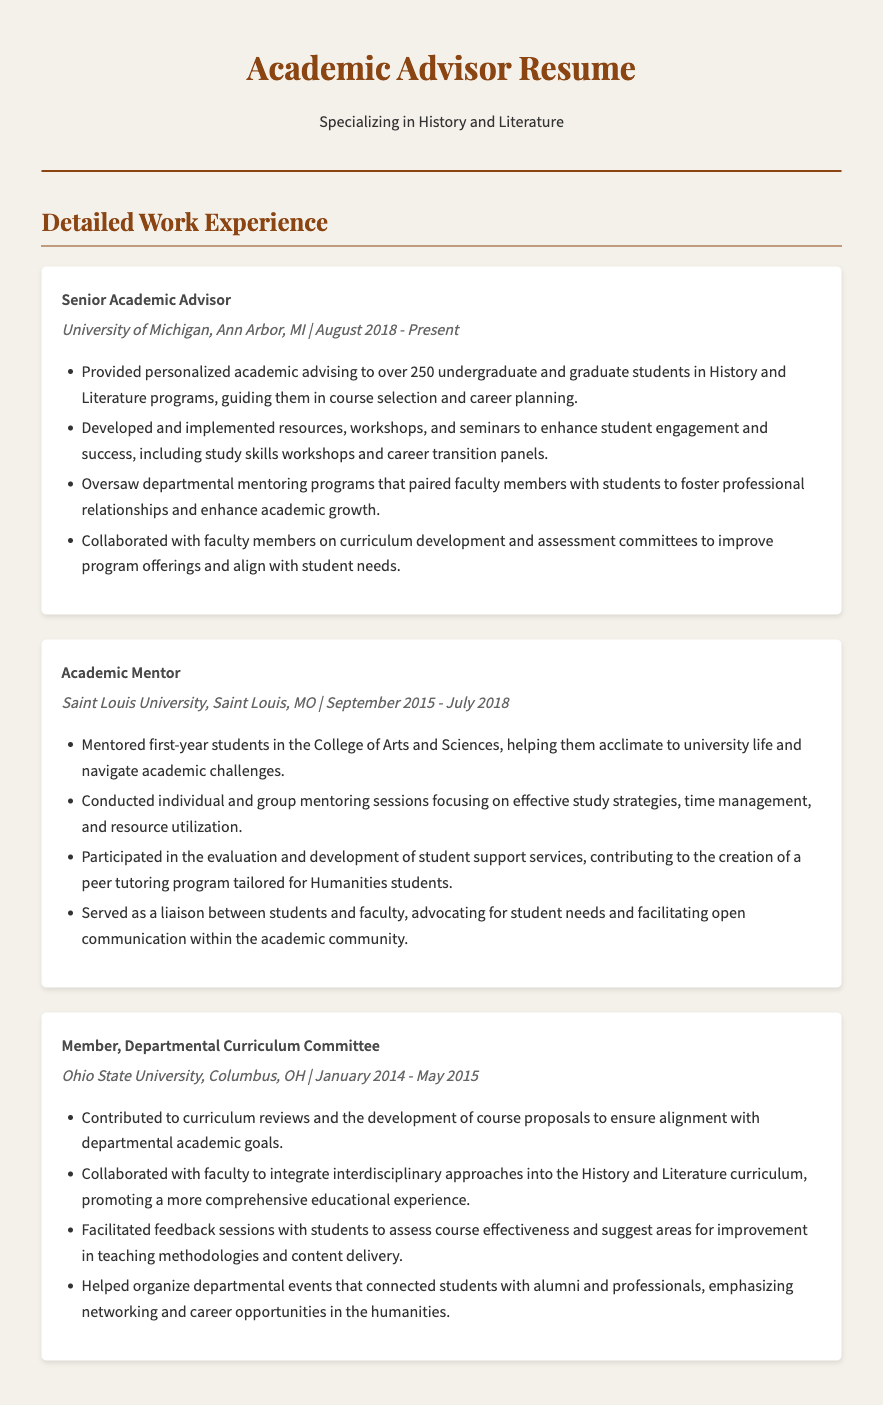what is the title of the current position? The current position mentioned is "Senior Academic Advisor."
Answer: Senior Academic Advisor which university is associated with the most recent work experience? The most recent work experience is at the "University of Michigan."
Answer: University of Michigan how many students did the Senior Academic Advisor provide personalized advising to? The document states that over 250 students received personalized advising.
Answer: over 250 what was a primary responsibility of the Academic Mentor role? One primary responsibility was to mentor first-year students in acclimating to university life.
Answer: mentor first-year students in which year did the Member of the Departmental Curriculum Committee work until? The Member of the Committee worked until "May 2015."
Answer: May 2015 what type of workshops did the Senior Academic Advisor develop? The workshops included "study skills workshops" and "career transition panels."
Answer: study skills workshops how long did the Academic Mentor position last? The Academic Mentor position lasted from "September 2015 to July 2018," which is approximately three years.
Answer: three years what was one way the Academic Mentor contributed to student support services? They contributed by developing a "peer tutoring program" for Humanities students.
Answer: peer tutoring program which committee was the advisor a member of at Ohio State University? The advisor was a member of the "Departmental Curriculum Committee."
Answer: Departmental Curriculum Committee 